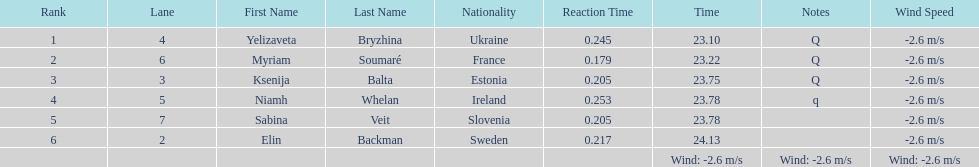Which player is from ireland? Niamh Whelan. 